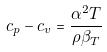<formula> <loc_0><loc_0><loc_500><loc_500>c _ { p } - c _ { v } = \frac { \alpha ^ { 2 } T } { \rho \beta _ { T } }</formula> 